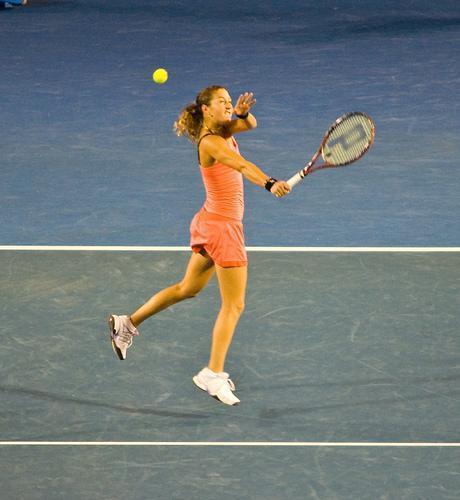How many players are in the photo?
Give a very brief answer. 1. 